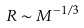<formula> <loc_0><loc_0><loc_500><loc_500>R \sim M ^ { - 1 / 3 }</formula> 